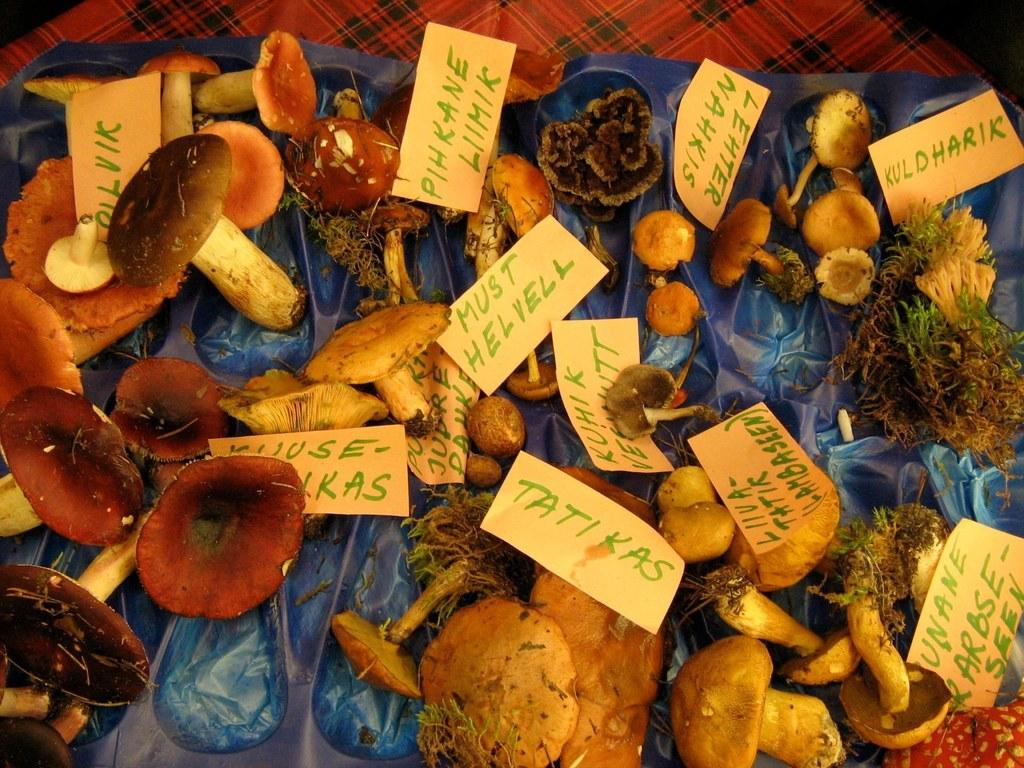What type of plants can be seen in the image? There are mushroom plants in the image. What objects are on the plastic cover in the image? There are papers on a plastic cover in the image. Can you describe the setting where the image was taken? The image may have been taken in a room. What is the chance of a car driving through the mushroom plants in the image? There is no car present in the image, so it is not possible to determine the chance of a car driving through the mushroom plants. 